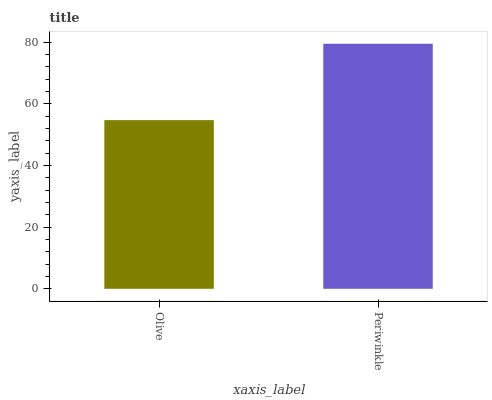Is Periwinkle the minimum?
Answer yes or no. No. Is Periwinkle greater than Olive?
Answer yes or no. Yes. Is Olive less than Periwinkle?
Answer yes or no. Yes. Is Olive greater than Periwinkle?
Answer yes or no. No. Is Periwinkle less than Olive?
Answer yes or no. No. Is Periwinkle the high median?
Answer yes or no. Yes. Is Olive the low median?
Answer yes or no. Yes. Is Olive the high median?
Answer yes or no. No. Is Periwinkle the low median?
Answer yes or no. No. 